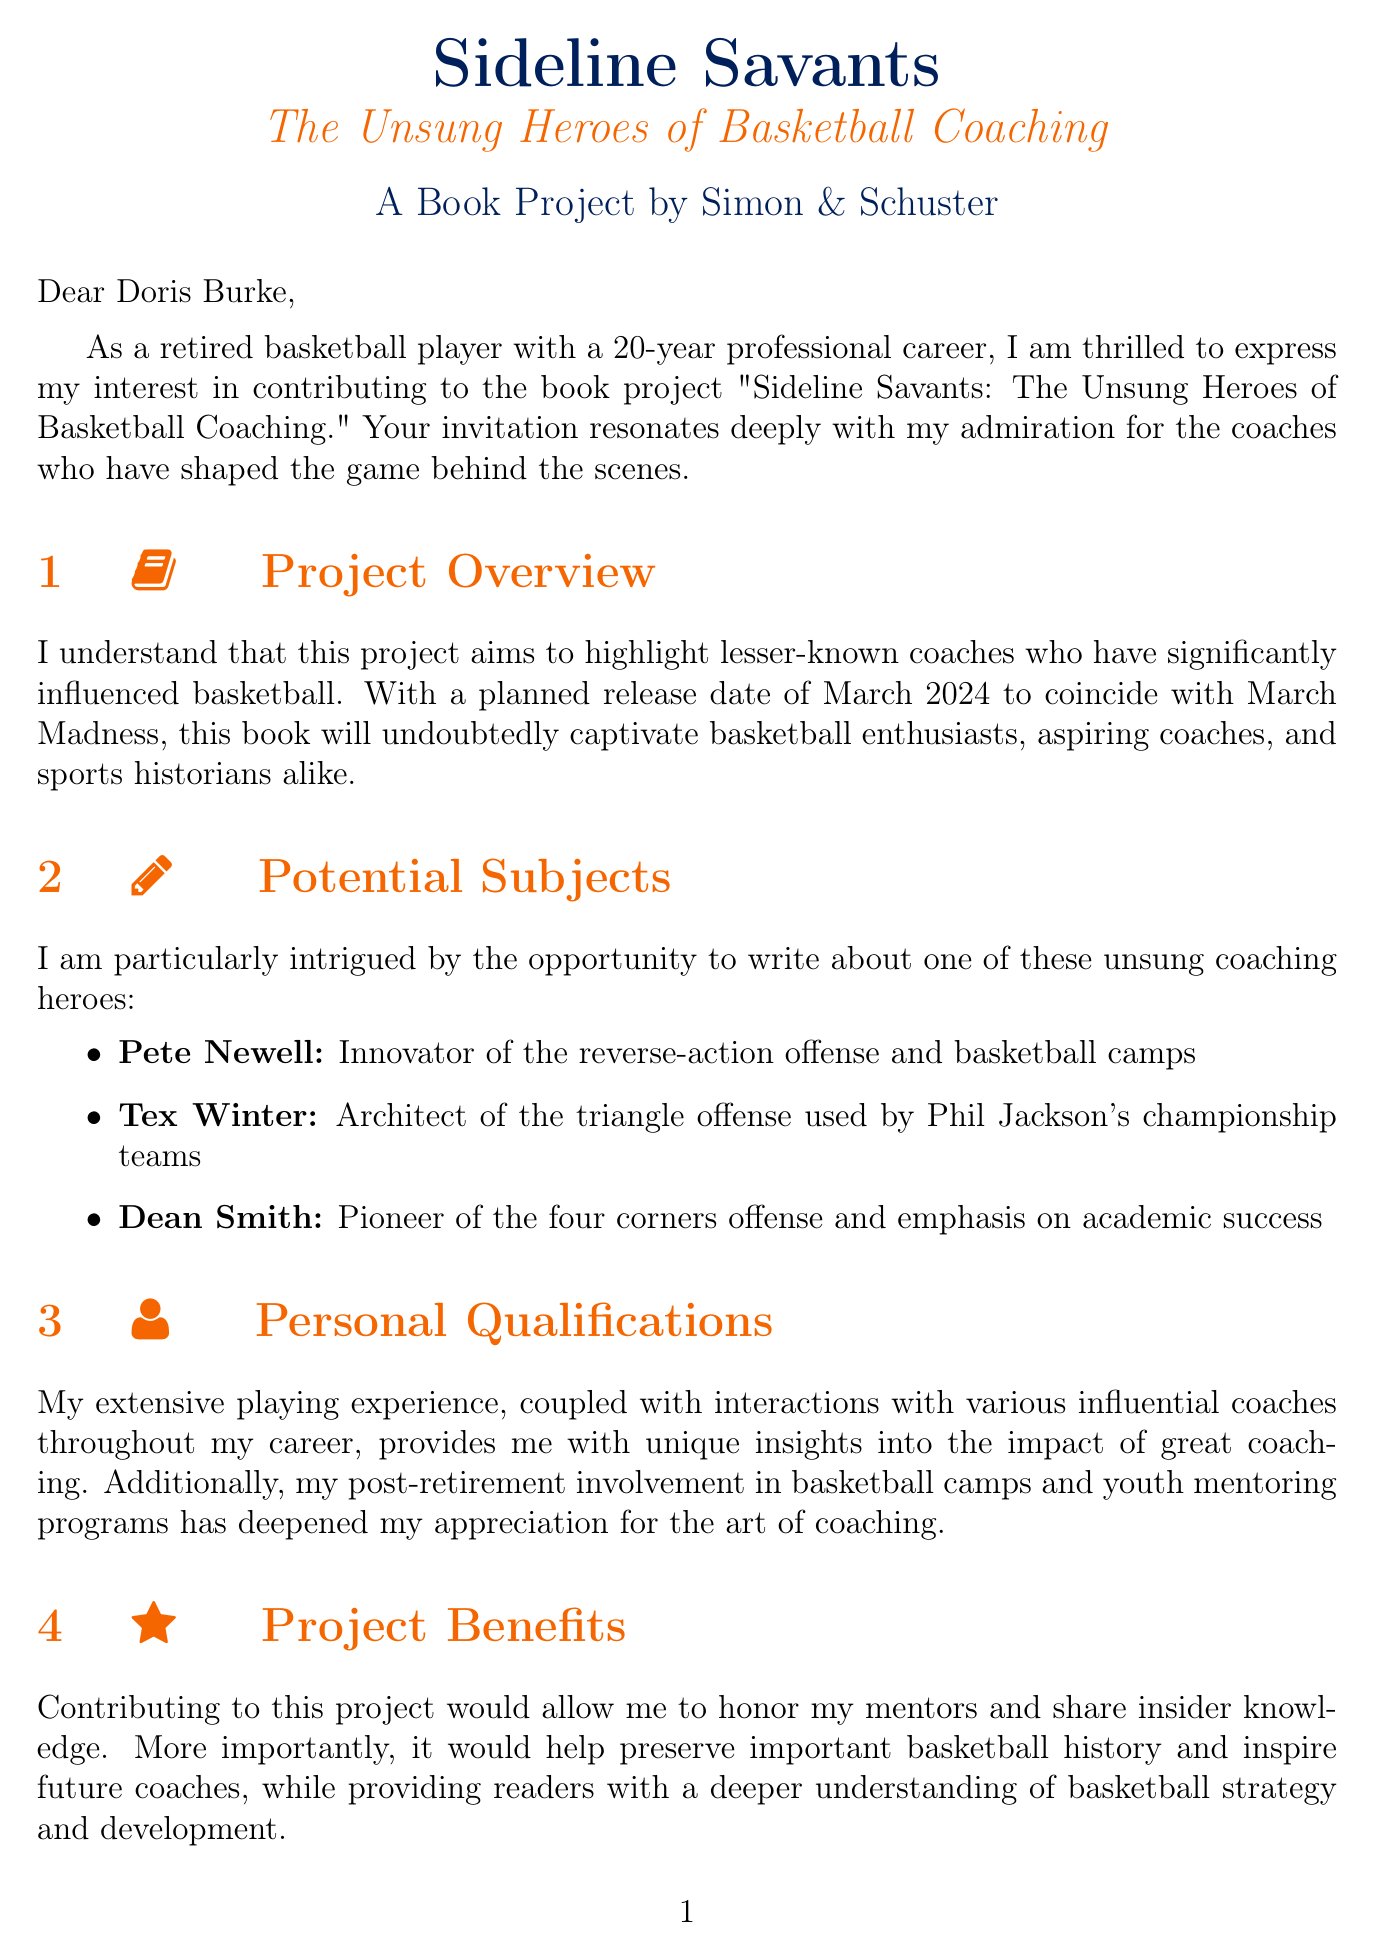what is the title of the book project? The title of the book project is explicitly stated as "Sideline Savants: The Unsung Heroes of Basketball Coaching."
Answer: Sideline Savants: The Unsung Heroes of Basketball Coaching who is the project lead? The project lead is mentioned as Doris Burke, who is a renowned basketball analyst and former college player.
Answer: Doris Burke what is the word count requirement for the essay? The document states that the contributor requirements include a 2000-word essay.
Answer: 2000-word when is the deadline for the first draft? The deadline for the first draft is specified in the logistical information section as September 30, 2023.
Answer: September 30, 2023 what is the planned release date of the book? The planned release date of the book is mentioned to coincide with March Madness, set for March 2024.
Answer: March 2024 which coaching hero is known for the triangle offense? The document lists Tex Winter as the coaching hero known for the triangle offense.
Answer: Tex Winter what compensation is offered for the contributor? The document outlines that the offered compensation includes a $5,000 honorarium plus 2% of book royalties.
Answer: $5,000 honorarium plus 2% of book royalties what is a potential impact of the project mentioned? The potential impact mentioned in the document includes contributing to the education of future generations in basketball.
Answer: Education of future generations in basketball what type of document is this? This document is a letter expressing interest in contributing to a book project.
Answer: Letter 